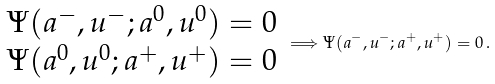<formula> <loc_0><loc_0><loc_500><loc_500>\begin{array} { l } \Psi ( a ^ { - } , u ^ { - } ; a ^ { 0 } , u ^ { 0 } ) = 0 \\ \Psi ( a ^ { 0 } , u ^ { 0 } ; a ^ { + } , u ^ { + } ) = 0 \end{array} \Longrightarrow \Psi ( a ^ { - } , u ^ { - } ; a ^ { + } , u ^ { + } ) = 0 \, .</formula> 